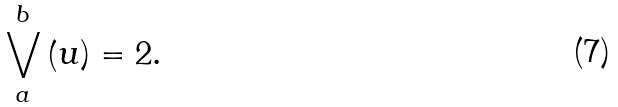Convert formula to latex. <formula><loc_0><loc_0><loc_500><loc_500>\bigvee _ { a } ^ { b } \left ( u \right ) = 2 .</formula> 